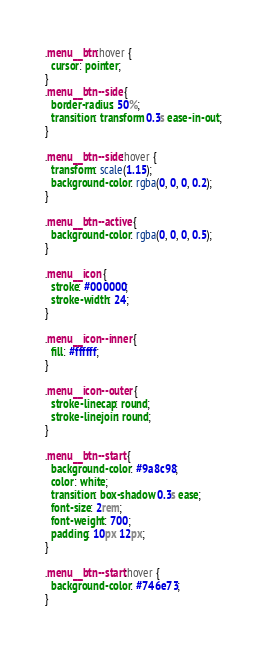<code> <loc_0><loc_0><loc_500><loc_500><_CSS_>
.menu__btn:hover {
  cursor: pointer;
}
.menu__btn--side {
  border-radius: 50%;
  transition: transform 0.3s ease-in-out;
}

.menu__btn--side:hover {
  transform: scale(1.15);
  background-color: rgba(0, 0, 0, 0.2);
}

.menu__btn--active {
  background-color: rgba(0, 0, 0, 0.5);
}

.menu__icon {
  stroke: #000000;
  stroke-width: 24;
}

.menu__icon--inner {
  fill: #ffffff;
}

.menu__icon--outer {
  stroke-linecap: round;
  stroke-linejoin: round;
}

.menu__btn--start {
  background-color: #9a8c98;
  color: white;
  transition: box-shadow 0.3s ease;
  font-size: 2rem;
  font-weight: 700;
  padding: 10px 12px;
}

.menu__btn--start:hover {
  background-color: #746e73;
}
</code> 